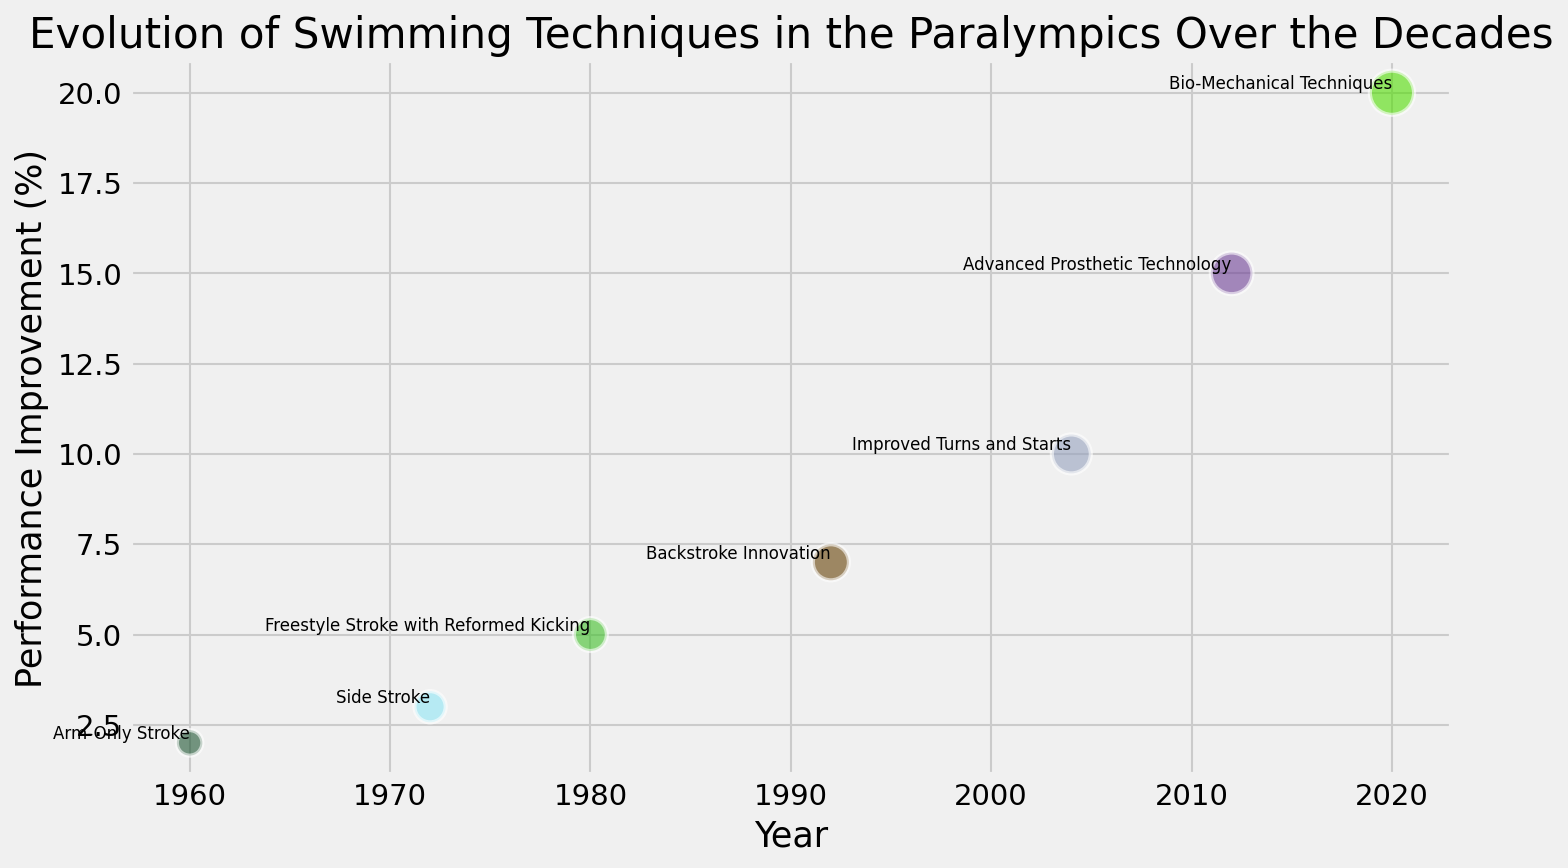Which swimming technique showed the highest performance improvement? To find the highest performance improvement, look for the bubble placed highest on the vertical axis. In this figure, "Bio-Mechanical Techniques" demonstrates the highest improvement at 20%.
Answer: Bio-Mechanical Techniques Which year saw a 7% performance improvement? To determine the year with a 7% performance improvement, locate the bubble with the vertical value of 7% on the chart and identify the corresponding year on the horizontal axis. This bubble is labeled as "Backstroke Innovation," and is situated at 1992.
Answer: 1992 Among techniques developed before the year 2000, when was the most popular technique introduced? Techniques introduced before the year 2000 include "Arm-Only Stroke," "Side Stroke," "Freestyle Stroke with Reformed Kicking," and "Backstroke Innovation." The bubble with the largest size (indicating popularity) among these techniques is "Backstroke Innovation" in 1992.
Answer: 1992 Identify the technique with the smallest popularity in 1960. Search for the bubble corresponding to the year 1960 and examine its size, which indicates popularity. It is labeled "Arm-Only Stroke" with the smallest bubble among all techniques, representing a popularity of 30.
Answer: Arm-Only Stroke How many performance improvements are greater than 10%? Review the vertical axis for performance improvements and count the number of bubbles positioned above the 10% mark. The bubbles are labeled as "Advanced Prosthetic Technology" at 15% and "Bio-Mechanical Techniques" at 20%, which totals to 2.
Answer: 2 What is the difference between the highest and the lowest performance improvements? Identify the highest performance improvement value (20% for "Bio-Mechanical Techniques") and the lowest (2% for "Arm-Only Stroke"). Compute the difference: 20% - 2% = 18%.
Answer: 18% Which technique introduced in or after 2000 has the highest popularity? Identify techniques introduced from 2000 onwards: "Improved Turns and Starts," "Advanced Prosthetic Technology," and "Bio-Mechanical Techniques." Compare their bubble sizes to find the largest, corresponding to "Bio-Mechanical Techniques" in 2020.
Answer: Bio-Mechanical Techniques Are there more techniques introduced before or after 2000? Count the number of techniques introduced before 2000 ("Arm-Only Stroke," "Side Stroke," "Freestyle Stroke with Reformed Kicking," "Backstroke Innovation") which totals 4. Then count techniques introduced after 2000 ("Improved Turns and Starts," "Advanced Prosthetic Technology," "Bio-Mechanical Techniques") which totals 3.
Answer: Before 2000 Which techniques have performance improvements that are multiples of 5? Observe the vertical axis for performance improvements and identify values that are multiples of 5%: 5% ("Freestyle Stroke with Reformed Kicking"), 10% ("Improved Turns and Starts"), and 20% ("Bio-Mechanical Techniques").
Answer: Freestyle Stroke with Reformed Kicking, Improved Turns and Starts, Bio-Mechanical Techniques Between 1960 and 1992, what is the trend in performance improvement? Analyze the vertical position of bubbles from 1960 to 1992. Performance improvement values rise from 2% (1960) to 3% (1972), 5% (1980), and 7% (1992). This indicates a generally increasing trend in performance improvements over time.
Answer: Increasing 